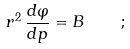<formula> <loc_0><loc_0><loc_500><loc_500>r ^ { 2 } \, \frac { d \varphi } { d p } = B \quad ;</formula> 